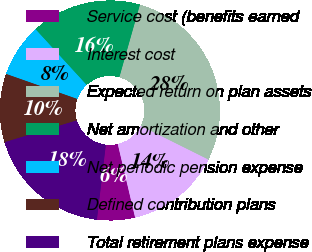<chart> <loc_0><loc_0><loc_500><loc_500><pie_chart><fcel>Service cost (benefits earned<fcel>Interest cost<fcel>Expected return on plan assets<fcel>Net amortization and other<fcel>Net periodic pension expense<fcel>Defined contribution plans<fcel>Total retirement plans expense<nl><fcel>5.57%<fcel>13.97%<fcel>27.95%<fcel>16.21%<fcel>7.81%<fcel>10.05%<fcel>18.45%<nl></chart> 